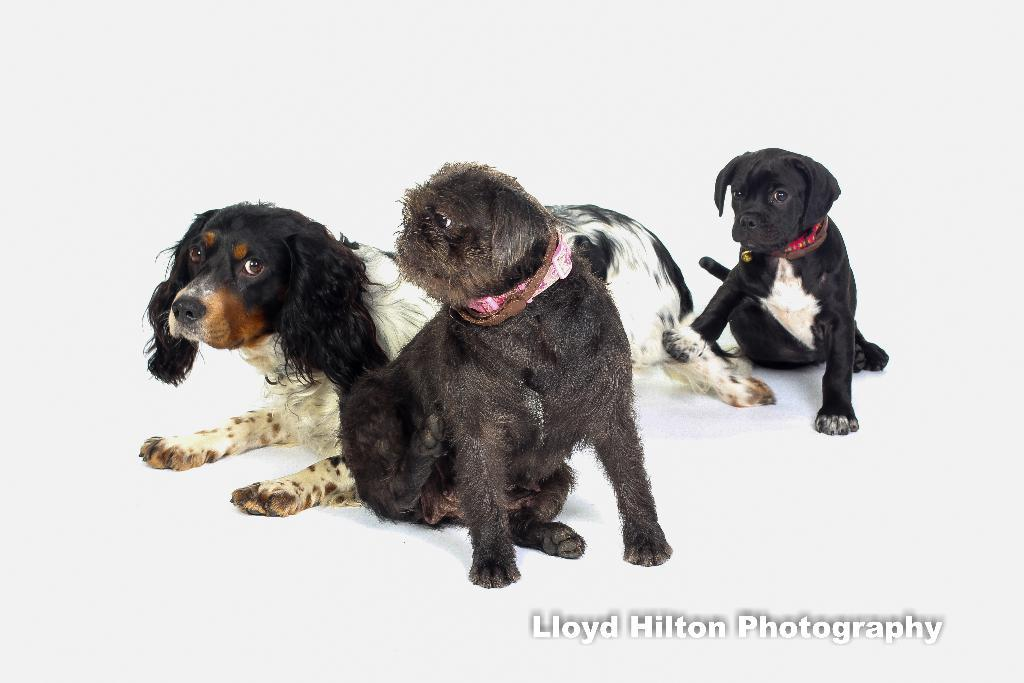How many dogs are visible in the image? There are three dogs visible in the image. Where are the dogs located in the image? One dog is on the right side, and two dogs are in the middle and on the left side of the image. What can be observed about the background of the image? The background of the image appears to be white. What type of order is the dog on the right side of the image following? There is no indication in the image that the dog is following any specific order. 